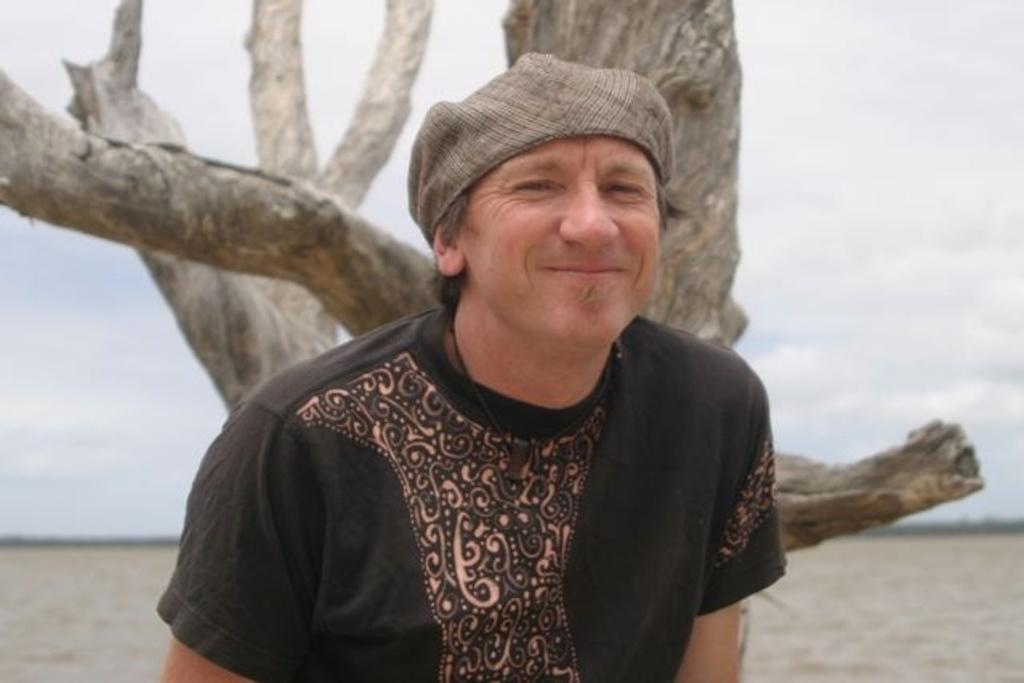What is the main subject of the image? There is a man in the image. What is the man wearing on his head? The man is wearing a cap. What can be seen in the background of the image? There are tree trunks, water, objects, and clouds in the sky in the background of the image. How many pizzas are being served at the society event in the image? There is no society event or pizzas present in the image. What type of pump is visible in the image? There is no pump visible in the image. 